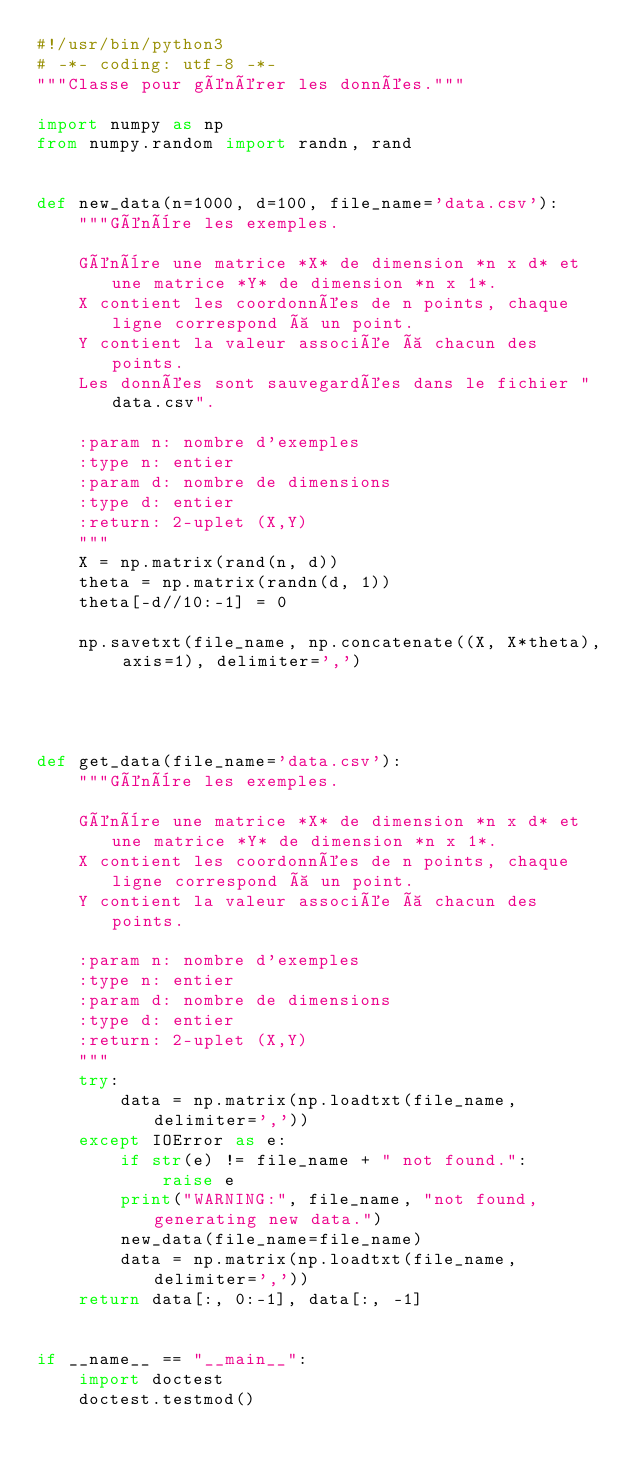<code> <loc_0><loc_0><loc_500><loc_500><_Python_>#!/usr/bin/python3
# -*- coding: utf-8 -*-
"""Classe pour générer les données."""

import numpy as np
from numpy.random import randn, rand


def new_data(n=1000, d=100, file_name='data.csv'):
    """Génère les exemples.

    Génère une matrice *X* de dimension *n x d* et une matrice *Y* de dimension *n x 1*.
    X contient les coordonnées de n points, chaque ligne correspond à un point.
    Y contient la valeur associée à chacun des points.
    Les données sont sauvegardées dans le fichier "data.csv".

    :param n: nombre d'exemples
    :type n: entier
    :param d: nombre de dimensions
    :type d: entier
    :return: 2-uplet (X,Y)
    """
    X = np.matrix(rand(n, d))
    theta = np.matrix(randn(d, 1))
    theta[-d//10:-1] = 0

    np.savetxt(file_name, np.concatenate((X, X*theta), axis=1), delimiter=',')




def get_data(file_name='data.csv'):
    """Génère les exemples.

    Génère une matrice *X* de dimension *n x d* et une matrice *Y* de dimension *n x 1*.
    X contient les coordonnées de n points, chaque ligne correspond à un point.
    Y contient la valeur associée à chacun des points.

    :param n: nombre d'exemples
    :type n: entier
    :param d: nombre de dimensions
    :type d: entier
    :return: 2-uplet (X,Y)
    """
    try:
        data = np.matrix(np.loadtxt(file_name, delimiter=','))
    except IOError as e:
        if str(e) != file_name + " not found.":
            raise e
        print("WARNING:", file_name, "not found, generating new data.")
        new_data(file_name=file_name)
        data = np.matrix(np.loadtxt(file_name, delimiter=','))
    return data[:, 0:-1], data[:, -1]


if __name__ == "__main__":
    import doctest
    doctest.testmod()
</code> 